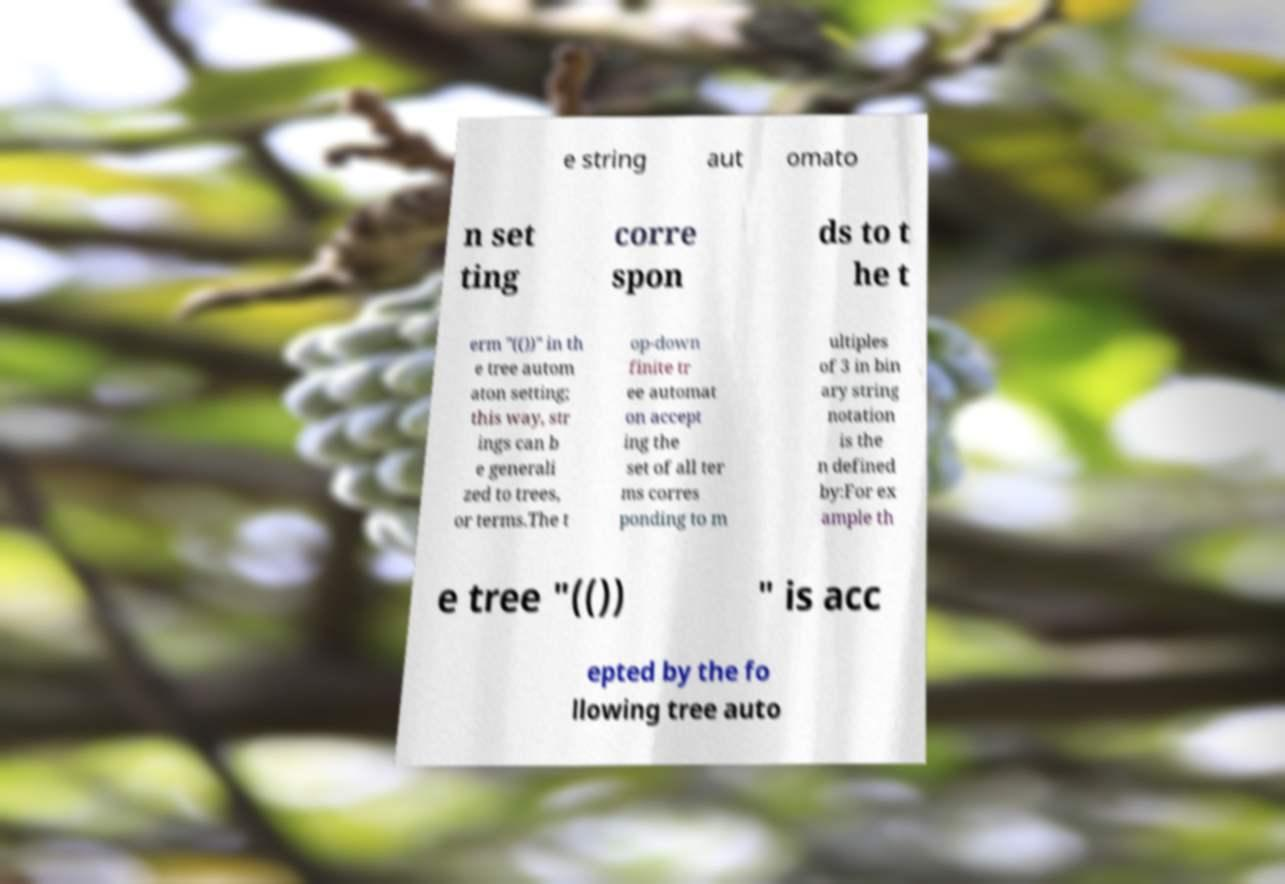What messages or text are displayed in this image? I need them in a readable, typed format. e string aut omato n set ting corre spon ds to t he t erm "(())" in th e tree autom aton setting; this way, str ings can b e generali zed to trees, or terms.The t op-down finite tr ee automat on accept ing the set of all ter ms corres ponding to m ultiples of 3 in bin ary string notation is the n defined by:For ex ample th e tree "(()) " is acc epted by the fo llowing tree auto 